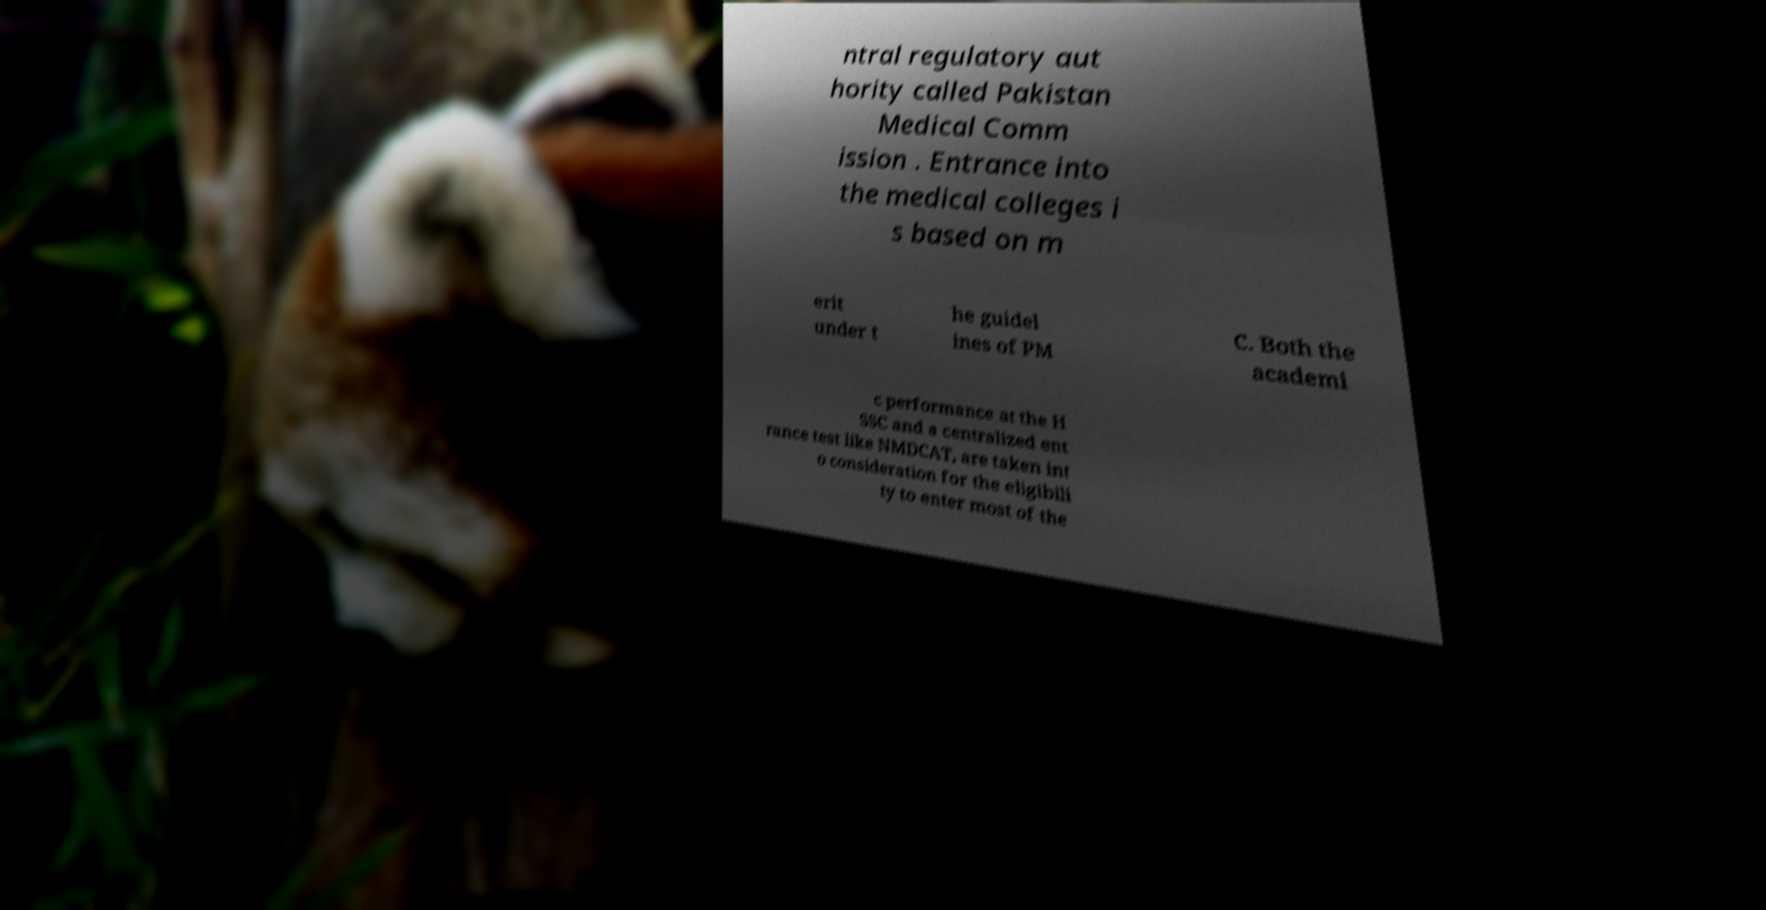I need the written content from this picture converted into text. Can you do that? ntral regulatory aut hority called Pakistan Medical Comm ission . Entrance into the medical colleges i s based on m erit under t he guidel ines of PM C. Both the academi c performance at the H SSC and a centralized ent rance test like NMDCAT, are taken int o consideration for the eligibili ty to enter most of the 